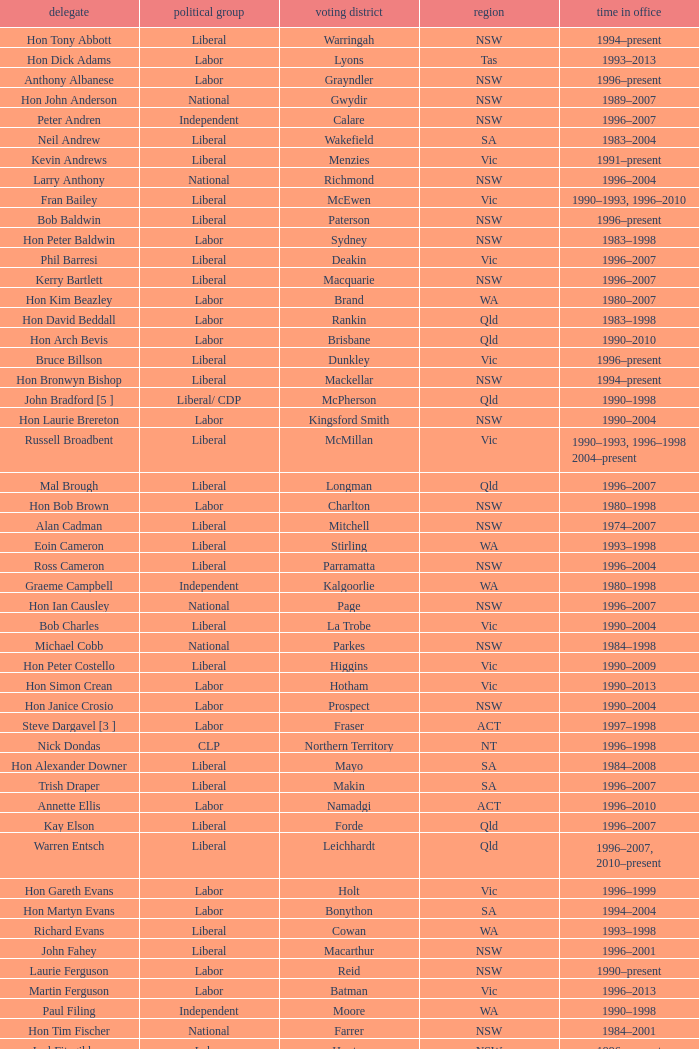What state did Hon David Beddall belong to? Qld. 